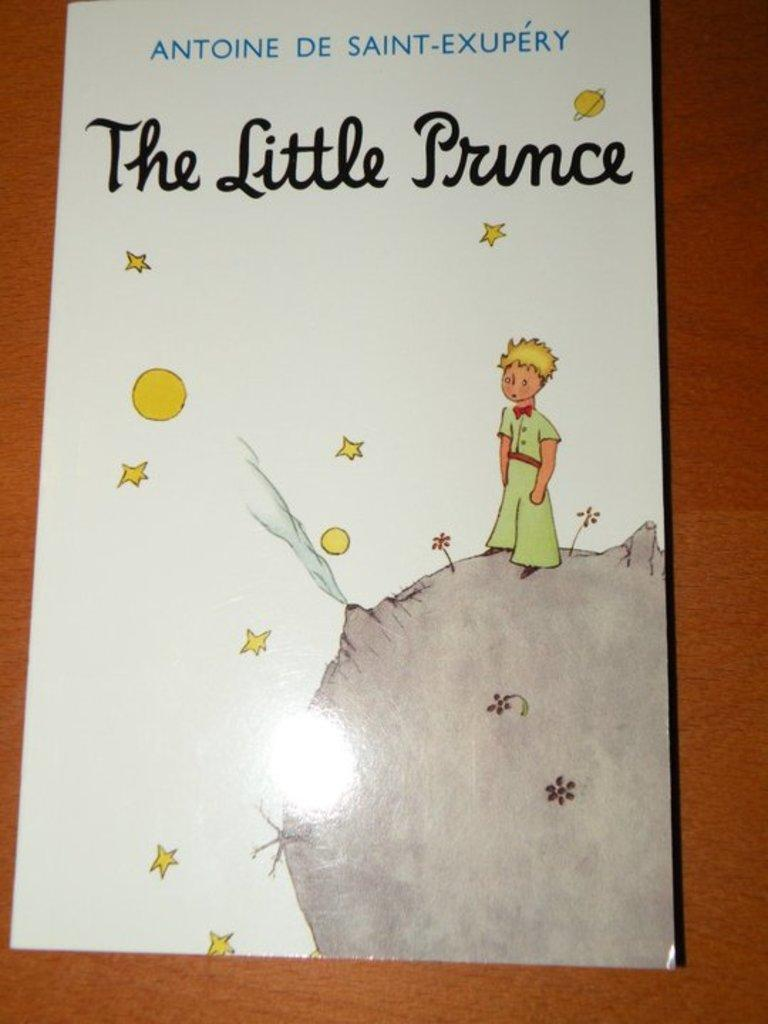<image>
Describe the image concisely. A children's book called The Little Prince is on a wooden table. 